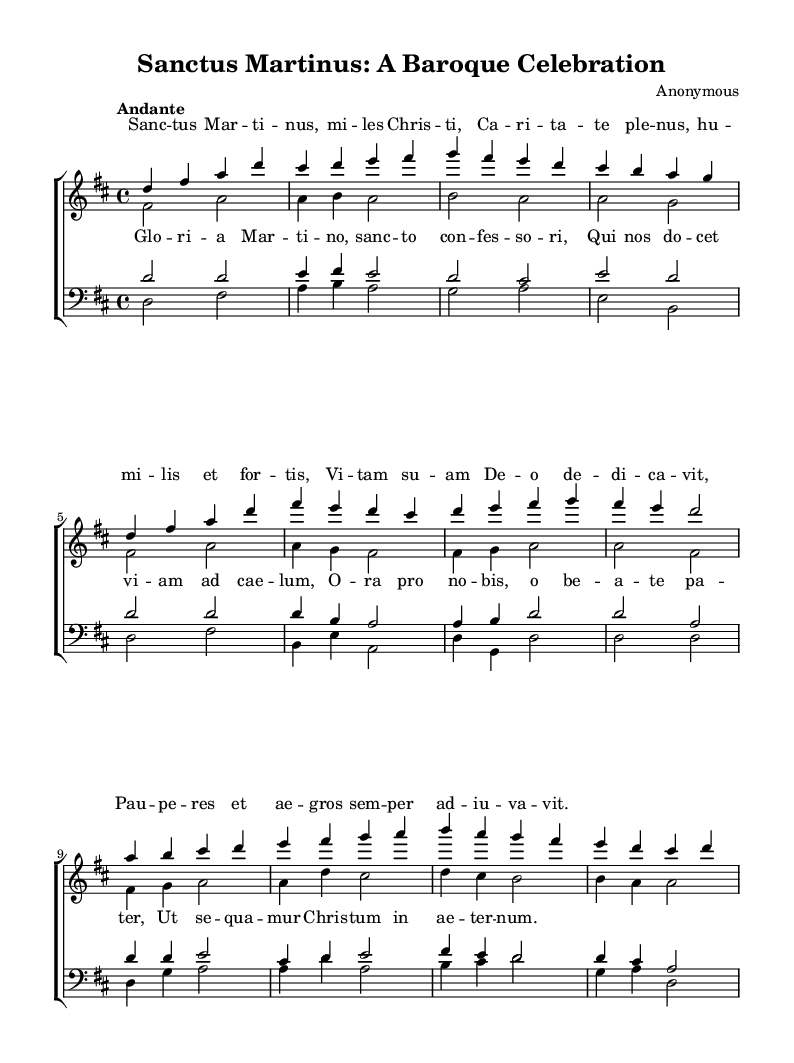What is the key signature of this music? The key signature is indicated at the beginning of the staff, with two sharps visible. This corresponds to the key of D major.
Answer: D major What is the time signature of this music? The time signature appears at the beginning, displayed as a 4 over 4, which indicates that there are four beats in each measure and that the quarter note receives one beat.
Answer: 4/4 What is the tempo marking of this piece? The tempo is specified at the beginning as "Andante," indicating a moderately slow tempo. This can usually be found as a term written above the staff.
Answer: Andante How many voices are present in the choral arrangement? By observing the score structure, it shows the presence of four distinct voices: soprano, alto, tenor, and bass, clearly indicated in separate staff sections.
Answer: Four What is the title of the choral work? The title is provided in the header section at the top of the sheet music, indicating what the piece is called. In this case, it is "Sanctus Martinus: A Baroque Celebration".
Answer: Sanctus Martinus: A Baroque Celebration What do the lyrics of the chorus focus on? The chorus lyrics emphasize the glorification of Saint Martin and call for intercession, as seen in the text provided under the choral arrangement. This requires a synthesis of understanding the themes of sanctity and devotion typical of Baroque choral works.
Answer: Glorification of Saint Martin What is a unique characteristic of Baroque choral music reflected in this piece? This piece features clear vocal lines that celebrate the lives of saints, which is a hallmark of Baroque choral compositions. It often includes ornate melodies and intricate counterpoint reflecting the reverence for sanctity.
Answer: Celebration of saints 